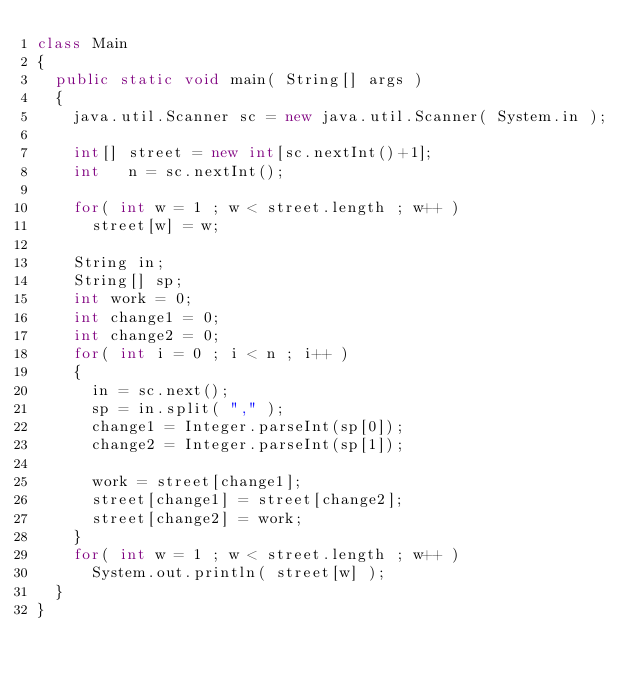Convert code to text. <code><loc_0><loc_0><loc_500><loc_500><_Java_>class Main
{
	public static void main( String[] args )
	{
		java.util.Scanner sc = new java.util.Scanner( System.in );
		
		int[] street = new int[sc.nextInt()+1];
		int   n = sc.nextInt();
		
		for( int w = 1 ; w < street.length ; w++ )
			street[w] = w;
			
		String in;
		String[] sp;
		int work = 0;
		int change1 = 0;
		int change2 = 0;
		for( int i = 0 ; i < n ; i++ )
		{
			in = sc.next();
			sp = in.split( "," );
			change1 = Integer.parseInt(sp[0]);
			change2 = Integer.parseInt(sp[1]);
			
			work = street[change1];
			street[change1] = street[change2];
			street[change2] = work;
		}
		for( int w = 1 ; w < street.length ; w++ )
			System.out.println( street[w] );
	}
}</code> 